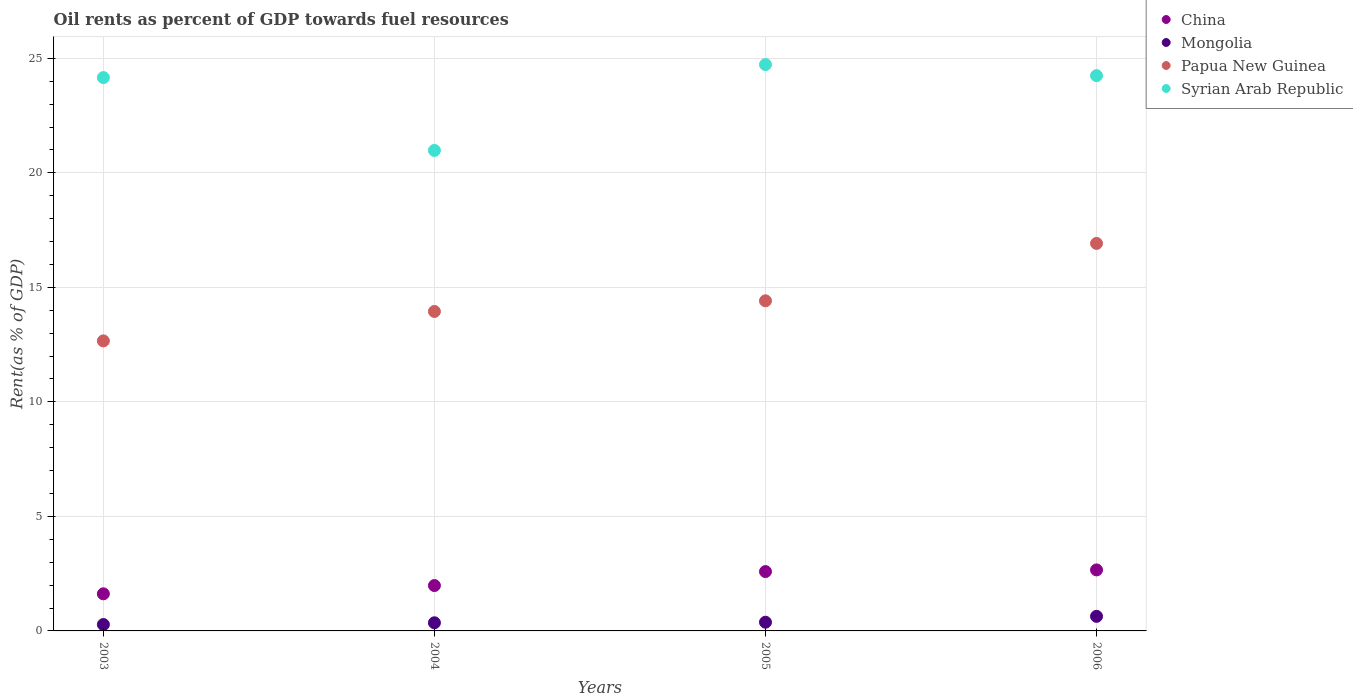What is the oil rent in China in 2005?
Your answer should be compact. 2.59. Across all years, what is the maximum oil rent in Mongolia?
Ensure brevity in your answer.  0.64. Across all years, what is the minimum oil rent in Mongolia?
Your answer should be very brief. 0.28. In which year was the oil rent in Mongolia maximum?
Make the answer very short. 2006. What is the total oil rent in China in the graph?
Your response must be concise. 8.85. What is the difference between the oil rent in Papua New Guinea in 2005 and that in 2006?
Provide a succinct answer. -2.51. What is the difference between the oil rent in Mongolia in 2004 and the oil rent in Syrian Arab Republic in 2005?
Your answer should be very brief. -24.37. What is the average oil rent in China per year?
Provide a succinct answer. 2.21. In the year 2006, what is the difference between the oil rent in Mongolia and oil rent in China?
Offer a terse response. -2.03. What is the ratio of the oil rent in China in 2003 to that in 2005?
Make the answer very short. 0.63. Is the oil rent in China in 2003 less than that in 2005?
Provide a short and direct response. Yes. What is the difference between the highest and the second highest oil rent in Papua New Guinea?
Your response must be concise. 2.51. What is the difference between the highest and the lowest oil rent in Mongolia?
Your response must be concise. 0.36. In how many years, is the oil rent in Papua New Guinea greater than the average oil rent in Papua New Guinea taken over all years?
Keep it short and to the point. 1. Is it the case that in every year, the sum of the oil rent in Syrian Arab Republic and oil rent in China  is greater than the sum of oil rent in Papua New Guinea and oil rent in Mongolia?
Your response must be concise. Yes. Is it the case that in every year, the sum of the oil rent in Mongolia and oil rent in Syrian Arab Republic  is greater than the oil rent in Papua New Guinea?
Make the answer very short. Yes. Is the oil rent in Mongolia strictly greater than the oil rent in Papua New Guinea over the years?
Offer a terse response. No. Is the oil rent in China strictly less than the oil rent in Syrian Arab Republic over the years?
Offer a terse response. Yes. How many years are there in the graph?
Ensure brevity in your answer.  4. What is the difference between two consecutive major ticks on the Y-axis?
Your answer should be very brief. 5. Does the graph contain any zero values?
Provide a succinct answer. No. Does the graph contain grids?
Keep it short and to the point. Yes. How many legend labels are there?
Offer a terse response. 4. What is the title of the graph?
Your answer should be compact. Oil rents as percent of GDP towards fuel resources. Does "Myanmar" appear as one of the legend labels in the graph?
Ensure brevity in your answer.  No. What is the label or title of the X-axis?
Your answer should be compact. Years. What is the label or title of the Y-axis?
Ensure brevity in your answer.  Rent(as % of GDP). What is the Rent(as % of GDP) in China in 2003?
Your response must be concise. 1.62. What is the Rent(as % of GDP) of Mongolia in 2003?
Make the answer very short. 0.28. What is the Rent(as % of GDP) of Papua New Guinea in 2003?
Give a very brief answer. 12.66. What is the Rent(as % of GDP) of Syrian Arab Republic in 2003?
Offer a terse response. 24.16. What is the Rent(as % of GDP) of China in 2004?
Ensure brevity in your answer.  1.98. What is the Rent(as % of GDP) in Mongolia in 2004?
Offer a terse response. 0.36. What is the Rent(as % of GDP) of Papua New Guinea in 2004?
Provide a short and direct response. 13.95. What is the Rent(as % of GDP) in Syrian Arab Republic in 2004?
Make the answer very short. 20.98. What is the Rent(as % of GDP) of China in 2005?
Keep it short and to the point. 2.59. What is the Rent(as % of GDP) in Mongolia in 2005?
Keep it short and to the point. 0.38. What is the Rent(as % of GDP) in Papua New Guinea in 2005?
Give a very brief answer. 14.41. What is the Rent(as % of GDP) of Syrian Arab Republic in 2005?
Your answer should be very brief. 24.73. What is the Rent(as % of GDP) in China in 2006?
Offer a very short reply. 2.66. What is the Rent(as % of GDP) of Mongolia in 2006?
Provide a succinct answer. 0.64. What is the Rent(as % of GDP) in Papua New Guinea in 2006?
Give a very brief answer. 16.92. What is the Rent(as % of GDP) in Syrian Arab Republic in 2006?
Give a very brief answer. 24.24. Across all years, what is the maximum Rent(as % of GDP) in China?
Keep it short and to the point. 2.66. Across all years, what is the maximum Rent(as % of GDP) of Mongolia?
Offer a terse response. 0.64. Across all years, what is the maximum Rent(as % of GDP) in Papua New Guinea?
Provide a succinct answer. 16.92. Across all years, what is the maximum Rent(as % of GDP) in Syrian Arab Republic?
Give a very brief answer. 24.73. Across all years, what is the minimum Rent(as % of GDP) in China?
Offer a very short reply. 1.62. Across all years, what is the minimum Rent(as % of GDP) in Mongolia?
Your answer should be compact. 0.28. Across all years, what is the minimum Rent(as % of GDP) in Papua New Guinea?
Your answer should be very brief. 12.66. Across all years, what is the minimum Rent(as % of GDP) of Syrian Arab Republic?
Ensure brevity in your answer.  20.98. What is the total Rent(as % of GDP) in China in the graph?
Provide a short and direct response. 8.86. What is the total Rent(as % of GDP) in Mongolia in the graph?
Provide a short and direct response. 1.65. What is the total Rent(as % of GDP) of Papua New Guinea in the graph?
Offer a very short reply. 57.94. What is the total Rent(as % of GDP) in Syrian Arab Republic in the graph?
Give a very brief answer. 94.11. What is the difference between the Rent(as % of GDP) of China in 2003 and that in 2004?
Your answer should be very brief. -0.36. What is the difference between the Rent(as % of GDP) of Mongolia in 2003 and that in 2004?
Your answer should be very brief. -0.08. What is the difference between the Rent(as % of GDP) of Papua New Guinea in 2003 and that in 2004?
Offer a very short reply. -1.28. What is the difference between the Rent(as % of GDP) in Syrian Arab Republic in 2003 and that in 2004?
Ensure brevity in your answer.  3.18. What is the difference between the Rent(as % of GDP) in China in 2003 and that in 2005?
Ensure brevity in your answer.  -0.97. What is the difference between the Rent(as % of GDP) in Mongolia in 2003 and that in 2005?
Your answer should be very brief. -0.1. What is the difference between the Rent(as % of GDP) of Papua New Guinea in 2003 and that in 2005?
Keep it short and to the point. -1.75. What is the difference between the Rent(as % of GDP) of Syrian Arab Republic in 2003 and that in 2005?
Ensure brevity in your answer.  -0.57. What is the difference between the Rent(as % of GDP) of China in 2003 and that in 2006?
Give a very brief answer. -1.04. What is the difference between the Rent(as % of GDP) of Mongolia in 2003 and that in 2006?
Offer a terse response. -0.36. What is the difference between the Rent(as % of GDP) of Papua New Guinea in 2003 and that in 2006?
Provide a short and direct response. -4.26. What is the difference between the Rent(as % of GDP) of Syrian Arab Republic in 2003 and that in 2006?
Offer a terse response. -0.08. What is the difference between the Rent(as % of GDP) in China in 2004 and that in 2005?
Make the answer very short. -0.61. What is the difference between the Rent(as % of GDP) in Mongolia in 2004 and that in 2005?
Provide a short and direct response. -0.02. What is the difference between the Rent(as % of GDP) in Papua New Guinea in 2004 and that in 2005?
Keep it short and to the point. -0.47. What is the difference between the Rent(as % of GDP) of Syrian Arab Republic in 2004 and that in 2005?
Your answer should be compact. -3.75. What is the difference between the Rent(as % of GDP) of China in 2004 and that in 2006?
Make the answer very short. -0.68. What is the difference between the Rent(as % of GDP) in Mongolia in 2004 and that in 2006?
Your answer should be very brief. -0.28. What is the difference between the Rent(as % of GDP) of Papua New Guinea in 2004 and that in 2006?
Offer a very short reply. -2.97. What is the difference between the Rent(as % of GDP) in Syrian Arab Republic in 2004 and that in 2006?
Provide a succinct answer. -3.27. What is the difference between the Rent(as % of GDP) in China in 2005 and that in 2006?
Your response must be concise. -0.07. What is the difference between the Rent(as % of GDP) of Mongolia in 2005 and that in 2006?
Your answer should be compact. -0.26. What is the difference between the Rent(as % of GDP) of Papua New Guinea in 2005 and that in 2006?
Provide a succinct answer. -2.51. What is the difference between the Rent(as % of GDP) of Syrian Arab Republic in 2005 and that in 2006?
Your answer should be compact. 0.48. What is the difference between the Rent(as % of GDP) of China in 2003 and the Rent(as % of GDP) of Mongolia in 2004?
Your answer should be very brief. 1.26. What is the difference between the Rent(as % of GDP) in China in 2003 and the Rent(as % of GDP) in Papua New Guinea in 2004?
Your response must be concise. -12.33. What is the difference between the Rent(as % of GDP) of China in 2003 and the Rent(as % of GDP) of Syrian Arab Republic in 2004?
Give a very brief answer. -19.36. What is the difference between the Rent(as % of GDP) of Mongolia in 2003 and the Rent(as % of GDP) of Papua New Guinea in 2004?
Make the answer very short. -13.67. What is the difference between the Rent(as % of GDP) of Mongolia in 2003 and the Rent(as % of GDP) of Syrian Arab Republic in 2004?
Keep it short and to the point. -20.7. What is the difference between the Rent(as % of GDP) of Papua New Guinea in 2003 and the Rent(as % of GDP) of Syrian Arab Republic in 2004?
Provide a short and direct response. -8.32. What is the difference between the Rent(as % of GDP) of China in 2003 and the Rent(as % of GDP) of Mongolia in 2005?
Ensure brevity in your answer.  1.24. What is the difference between the Rent(as % of GDP) of China in 2003 and the Rent(as % of GDP) of Papua New Guinea in 2005?
Provide a short and direct response. -12.79. What is the difference between the Rent(as % of GDP) in China in 2003 and the Rent(as % of GDP) in Syrian Arab Republic in 2005?
Your response must be concise. -23.11. What is the difference between the Rent(as % of GDP) in Mongolia in 2003 and the Rent(as % of GDP) in Papua New Guinea in 2005?
Your response must be concise. -14.13. What is the difference between the Rent(as % of GDP) of Mongolia in 2003 and the Rent(as % of GDP) of Syrian Arab Republic in 2005?
Offer a very short reply. -24.45. What is the difference between the Rent(as % of GDP) of Papua New Guinea in 2003 and the Rent(as % of GDP) of Syrian Arab Republic in 2005?
Keep it short and to the point. -12.06. What is the difference between the Rent(as % of GDP) of China in 2003 and the Rent(as % of GDP) of Mongolia in 2006?
Give a very brief answer. 0.98. What is the difference between the Rent(as % of GDP) in China in 2003 and the Rent(as % of GDP) in Papua New Guinea in 2006?
Offer a terse response. -15.3. What is the difference between the Rent(as % of GDP) in China in 2003 and the Rent(as % of GDP) in Syrian Arab Republic in 2006?
Provide a short and direct response. -22.62. What is the difference between the Rent(as % of GDP) in Mongolia in 2003 and the Rent(as % of GDP) in Papua New Guinea in 2006?
Keep it short and to the point. -16.64. What is the difference between the Rent(as % of GDP) in Mongolia in 2003 and the Rent(as % of GDP) in Syrian Arab Republic in 2006?
Your answer should be very brief. -23.97. What is the difference between the Rent(as % of GDP) of Papua New Guinea in 2003 and the Rent(as % of GDP) of Syrian Arab Republic in 2006?
Ensure brevity in your answer.  -11.58. What is the difference between the Rent(as % of GDP) in China in 2004 and the Rent(as % of GDP) in Mongolia in 2005?
Give a very brief answer. 1.6. What is the difference between the Rent(as % of GDP) of China in 2004 and the Rent(as % of GDP) of Papua New Guinea in 2005?
Make the answer very short. -12.43. What is the difference between the Rent(as % of GDP) in China in 2004 and the Rent(as % of GDP) in Syrian Arab Republic in 2005?
Provide a short and direct response. -22.75. What is the difference between the Rent(as % of GDP) of Mongolia in 2004 and the Rent(as % of GDP) of Papua New Guinea in 2005?
Ensure brevity in your answer.  -14.06. What is the difference between the Rent(as % of GDP) in Mongolia in 2004 and the Rent(as % of GDP) in Syrian Arab Republic in 2005?
Keep it short and to the point. -24.37. What is the difference between the Rent(as % of GDP) in Papua New Guinea in 2004 and the Rent(as % of GDP) in Syrian Arab Republic in 2005?
Your response must be concise. -10.78. What is the difference between the Rent(as % of GDP) of China in 2004 and the Rent(as % of GDP) of Mongolia in 2006?
Your response must be concise. 1.34. What is the difference between the Rent(as % of GDP) in China in 2004 and the Rent(as % of GDP) in Papua New Guinea in 2006?
Your answer should be compact. -14.94. What is the difference between the Rent(as % of GDP) in China in 2004 and the Rent(as % of GDP) in Syrian Arab Republic in 2006?
Make the answer very short. -22.26. What is the difference between the Rent(as % of GDP) in Mongolia in 2004 and the Rent(as % of GDP) in Papua New Guinea in 2006?
Ensure brevity in your answer.  -16.56. What is the difference between the Rent(as % of GDP) of Mongolia in 2004 and the Rent(as % of GDP) of Syrian Arab Republic in 2006?
Offer a terse response. -23.89. What is the difference between the Rent(as % of GDP) in Papua New Guinea in 2004 and the Rent(as % of GDP) in Syrian Arab Republic in 2006?
Make the answer very short. -10.3. What is the difference between the Rent(as % of GDP) of China in 2005 and the Rent(as % of GDP) of Mongolia in 2006?
Keep it short and to the point. 1.95. What is the difference between the Rent(as % of GDP) of China in 2005 and the Rent(as % of GDP) of Papua New Guinea in 2006?
Your response must be concise. -14.33. What is the difference between the Rent(as % of GDP) of China in 2005 and the Rent(as % of GDP) of Syrian Arab Republic in 2006?
Offer a very short reply. -21.65. What is the difference between the Rent(as % of GDP) in Mongolia in 2005 and the Rent(as % of GDP) in Papua New Guinea in 2006?
Your response must be concise. -16.54. What is the difference between the Rent(as % of GDP) in Mongolia in 2005 and the Rent(as % of GDP) in Syrian Arab Republic in 2006?
Provide a succinct answer. -23.86. What is the difference between the Rent(as % of GDP) of Papua New Guinea in 2005 and the Rent(as % of GDP) of Syrian Arab Republic in 2006?
Keep it short and to the point. -9.83. What is the average Rent(as % of GDP) in China per year?
Your answer should be compact. 2.21. What is the average Rent(as % of GDP) of Mongolia per year?
Provide a succinct answer. 0.41. What is the average Rent(as % of GDP) in Papua New Guinea per year?
Your answer should be very brief. 14.49. What is the average Rent(as % of GDP) in Syrian Arab Republic per year?
Keep it short and to the point. 23.53. In the year 2003, what is the difference between the Rent(as % of GDP) of China and Rent(as % of GDP) of Mongolia?
Provide a short and direct response. 1.34. In the year 2003, what is the difference between the Rent(as % of GDP) of China and Rent(as % of GDP) of Papua New Guinea?
Make the answer very short. -11.04. In the year 2003, what is the difference between the Rent(as % of GDP) of China and Rent(as % of GDP) of Syrian Arab Republic?
Offer a very short reply. -22.54. In the year 2003, what is the difference between the Rent(as % of GDP) in Mongolia and Rent(as % of GDP) in Papua New Guinea?
Give a very brief answer. -12.38. In the year 2003, what is the difference between the Rent(as % of GDP) of Mongolia and Rent(as % of GDP) of Syrian Arab Republic?
Give a very brief answer. -23.88. In the year 2003, what is the difference between the Rent(as % of GDP) in Papua New Guinea and Rent(as % of GDP) in Syrian Arab Republic?
Your response must be concise. -11.5. In the year 2004, what is the difference between the Rent(as % of GDP) of China and Rent(as % of GDP) of Mongolia?
Ensure brevity in your answer.  1.63. In the year 2004, what is the difference between the Rent(as % of GDP) in China and Rent(as % of GDP) in Papua New Guinea?
Offer a terse response. -11.97. In the year 2004, what is the difference between the Rent(as % of GDP) in China and Rent(as % of GDP) in Syrian Arab Republic?
Your response must be concise. -19. In the year 2004, what is the difference between the Rent(as % of GDP) in Mongolia and Rent(as % of GDP) in Papua New Guinea?
Provide a succinct answer. -13.59. In the year 2004, what is the difference between the Rent(as % of GDP) of Mongolia and Rent(as % of GDP) of Syrian Arab Republic?
Provide a succinct answer. -20.62. In the year 2004, what is the difference between the Rent(as % of GDP) in Papua New Guinea and Rent(as % of GDP) in Syrian Arab Republic?
Offer a very short reply. -7.03. In the year 2005, what is the difference between the Rent(as % of GDP) in China and Rent(as % of GDP) in Mongolia?
Give a very brief answer. 2.21. In the year 2005, what is the difference between the Rent(as % of GDP) of China and Rent(as % of GDP) of Papua New Guinea?
Offer a very short reply. -11.82. In the year 2005, what is the difference between the Rent(as % of GDP) in China and Rent(as % of GDP) in Syrian Arab Republic?
Your answer should be very brief. -22.14. In the year 2005, what is the difference between the Rent(as % of GDP) of Mongolia and Rent(as % of GDP) of Papua New Guinea?
Give a very brief answer. -14.03. In the year 2005, what is the difference between the Rent(as % of GDP) in Mongolia and Rent(as % of GDP) in Syrian Arab Republic?
Your answer should be compact. -24.35. In the year 2005, what is the difference between the Rent(as % of GDP) of Papua New Guinea and Rent(as % of GDP) of Syrian Arab Republic?
Your response must be concise. -10.31. In the year 2006, what is the difference between the Rent(as % of GDP) in China and Rent(as % of GDP) in Mongolia?
Your response must be concise. 2.03. In the year 2006, what is the difference between the Rent(as % of GDP) of China and Rent(as % of GDP) of Papua New Guinea?
Your answer should be compact. -14.26. In the year 2006, what is the difference between the Rent(as % of GDP) of China and Rent(as % of GDP) of Syrian Arab Republic?
Your answer should be compact. -21.58. In the year 2006, what is the difference between the Rent(as % of GDP) in Mongolia and Rent(as % of GDP) in Papua New Guinea?
Provide a short and direct response. -16.28. In the year 2006, what is the difference between the Rent(as % of GDP) of Mongolia and Rent(as % of GDP) of Syrian Arab Republic?
Offer a very short reply. -23.61. In the year 2006, what is the difference between the Rent(as % of GDP) of Papua New Guinea and Rent(as % of GDP) of Syrian Arab Republic?
Your response must be concise. -7.33. What is the ratio of the Rent(as % of GDP) of China in 2003 to that in 2004?
Provide a short and direct response. 0.82. What is the ratio of the Rent(as % of GDP) in Mongolia in 2003 to that in 2004?
Provide a succinct answer. 0.78. What is the ratio of the Rent(as % of GDP) in Papua New Guinea in 2003 to that in 2004?
Your answer should be very brief. 0.91. What is the ratio of the Rent(as % of GDP) in Syrian Arab Republic in 2003 to that in 2004?
Your response must be concise. 1.15. What is the ratio of the Rent(as % of GDP) of China in 2003 to that in 2005?
Offer a terse response. 0.63. What is the ratio of the Rent(as % of GDP) in Mongolia in 2003 to that in 2005?
Provide a succinct answer. 0.73. What is the ratio of the Rent(as % of GDP) of Papua New Guinea in 2003 to that in 2005?
Make the answer very short. 0.88. What is the ratio of the Rent(as % of GDP) in China in 2003 to that in 2006?
Your response must be concise. 0.61. What is the ratio of the Rent(as % of GDP) in Mongolia in 2003 to that in 2006?
Offer a terse response. 0.44. What is the ratio of the Rent(as % of GDP) of Papua New Guinea in 2003 to that in 2006?
Ensure brevity in your answer.  0.75. What is the ratio of the Rent(as % of GDP) in Syrian Arab Republic in 2003 to that in 2006?
Keep it short and to the point. 1. What is the ratio of the Rent(as % of GDP) in China in 2004 to that in 2005?
Ensure brevity in your answer.  0.76. What is the ratio of the Rent(as % of GDP) of Mongolia in 2004 to that in 2005?
Provide a succinct answer. 0.94. What is the ratio of the Rent(as % of GDP) of Syrian Arab Republic in 2004 to that in 2005?
Your answer should be very brief. 0.85. What is the ratio of the Rent(as % of GDP) in China in 2004 to that in 2006?
Offer a very short reply. 0.74. What is the ratio of the Rent(as % of GDP) in Mongolia in 2004 to that in 2006?
Offer a terse response. 0.56. What is the ratio of the Rent(as % of GDP) of Papua New Guinea in 2004 to that in 2006?
Offer a very short reply. 0.82. What is the ratio of the Rent(as % of GDP) of Syrian Arab Republic in 2004 to that in 2006?
Your response must be concise. 0.87. What is the ratio of the Rent(as % of GDP) of China in 2005 to that in 2006?
Offer a very short reply. 0.97. What is the ratio of the Rent(as % of GDP) in Mongolia in 2005 to that in 2006?
Give a very brief answer. 0.6. What is the ratio of the Rent(as % of GDP) in Papua New Guinea in 2005 to that in 2006?
Your response must be concise. 0.85. What is the ratio of the Rent(as % of GDP) of Syrian Arab Republic in 2005 to that in 2006?
Ensure brevity in your answer.  1.02. What is the difference between the highest and the second highest Rent(as % of GDP) in China?
Your answer should be compact. 0.07. What is the difference between the highest and the second highest Rent(as % of GDP) in Mongolia?
Offer a very short reply. 0.26. What is the difference between the highest and the second highest Rent(as % of GDP) of Papua New Guinea?
Ensure brevity in your answer.  2.51. What is the difference between the highest and the second highest Rent(as % of GDP) of Syrian Arab Republic?
Offer a terse response. 0.48. What is the difference between the highest and the lowest Rent(as % of GDP) in China?
Keep it short and to the point. 1.04. What is the difference between the highest and the lowest Rent(as % of GDP) in Mongolia?
Give a very brief answer. 0.36. What is the difference between the highest and the lowest Rent(as % of GDP) of Papua New Guinea?
Provide a succinct answer. 4.26. What is the difference between the highest and the lowest Rent(as % of GDP) in Syrian Arab Republic?
Your answer should be very brief. 3.75. 